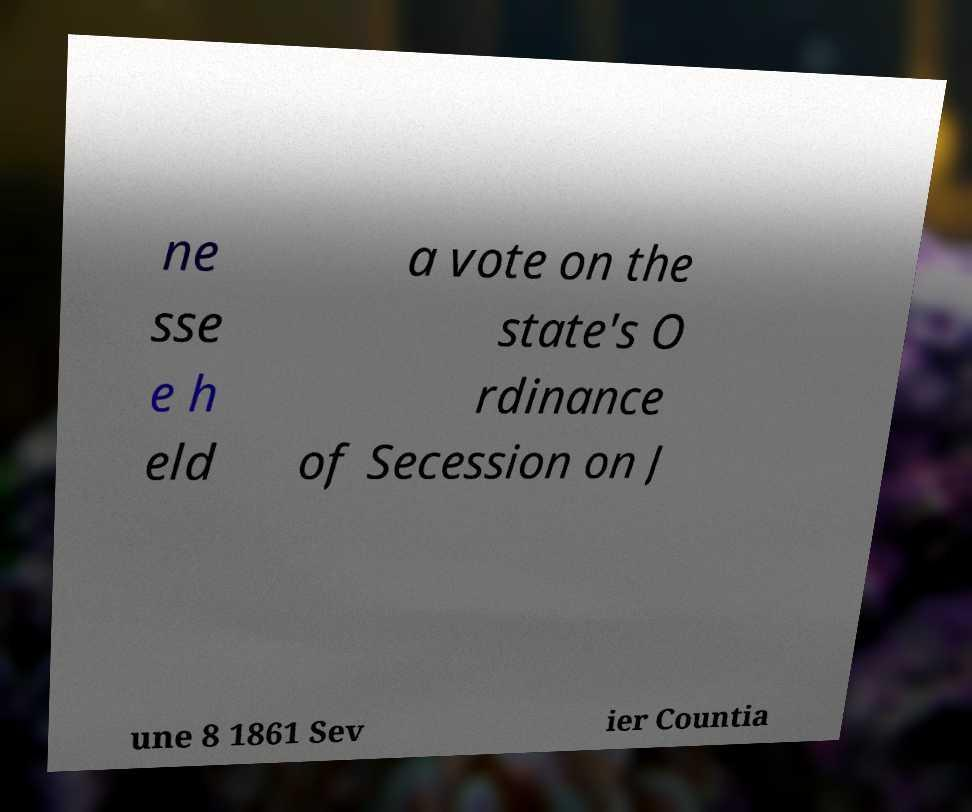Could you extract and type out the text from this image? ne sse e h eld a vote on the state's O rdinance of Secession on J une 8 1861 Sev ier Countia 